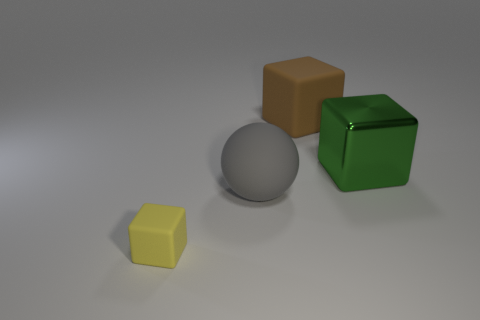Add 4 large spheres. How many objects exist? 8 Subtract all blocks. How many objects are left? 1 Add 2 tiny matte objects. How many tiny matte objects exist? 3 Subtract 0 purple balls. How many objects are left? 4 Subtract all tiny yellow rubber blocks. Subtract all tiny green blocks. How many objects are left? 3 Add 3 big brown matte objects. How many big brown matte objects are left? 4 